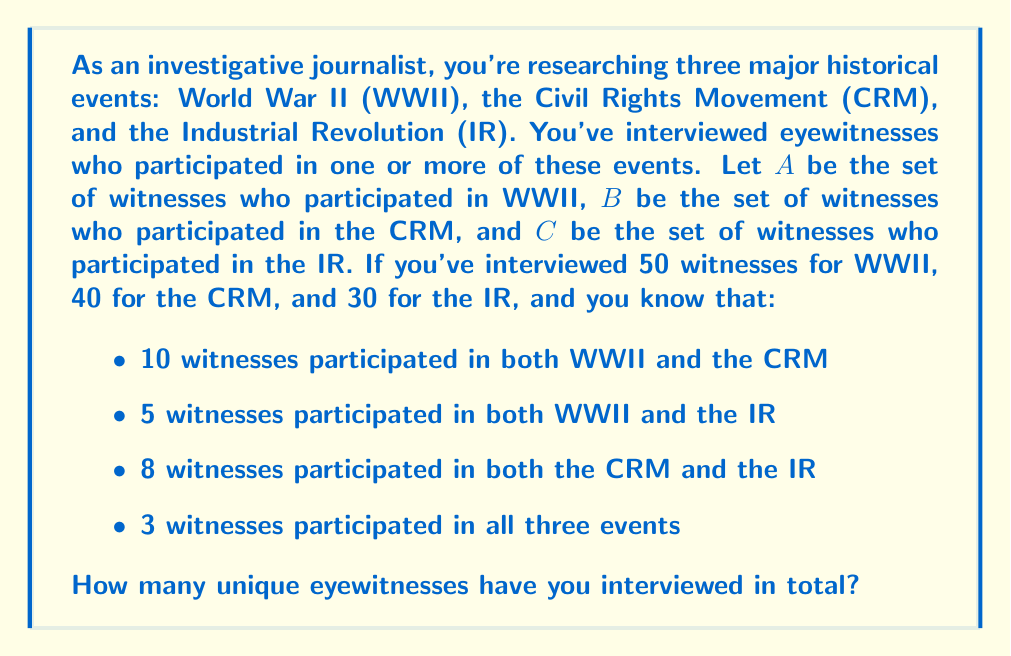Provide a solution to this math problem. To solve this problem, we'll use the Principle of Inclusion-Exclusion (PIE) for three sets. Let's break it down step by step:

1) First, let's define our sets:
   A: Witnesses who participated in WWII
   B: Witnesses who participated in the CRM
   C: Witnesses who participated in the IR

2) We're given:
   $|A| = 50$, $|B| = 40$, $|C| = 30$
   $|A \cap B| = 10$, $|A \cap C| = 5$, $|B \cap C| = 8$
   $|A \cap B \cap C| = 3$

3) The PIE formula for three sets is:

   $$|A \cup B \cup C| = |A| + |B| + |C| - |A \cap B| - |A \cap C| - |B \cap C| + |A \cap B \cap C|$$

4) Let's substitute our known values:

   $$|A \cup B \cup C| = 50 + 40 + 30 - 10 - 5 - 8 + 3$$

5) Now we can calculate:

   $$|A \cup B \cup C| = 120 - 23 + 3 = 100$$

Therefore, the total number of unique eyewitnesses interviewed is 100.
Answer: 100 unique eyewitnesses 